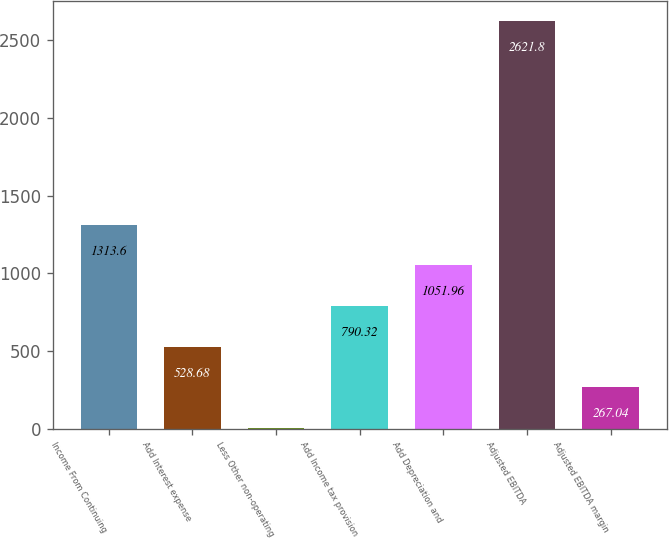<chart> <loc_0><loc_0><loc_500><loc_500><bar_chart><fcel>Income From Continuing<fcel>Add Interest expense<fcel>Less Other non-operating<fcel>Add Income tax provision<fcel>Add Depreciation and<fcel>Adjusted EBITDA<fcel>Adjusted EBITDA margin<nl><fcel>1313.6<fcel>528.68<fcel>5.4<fcel>790.32<fcel>1051.96<fcel>2621.8<fcel>267.04<nl></chart> 